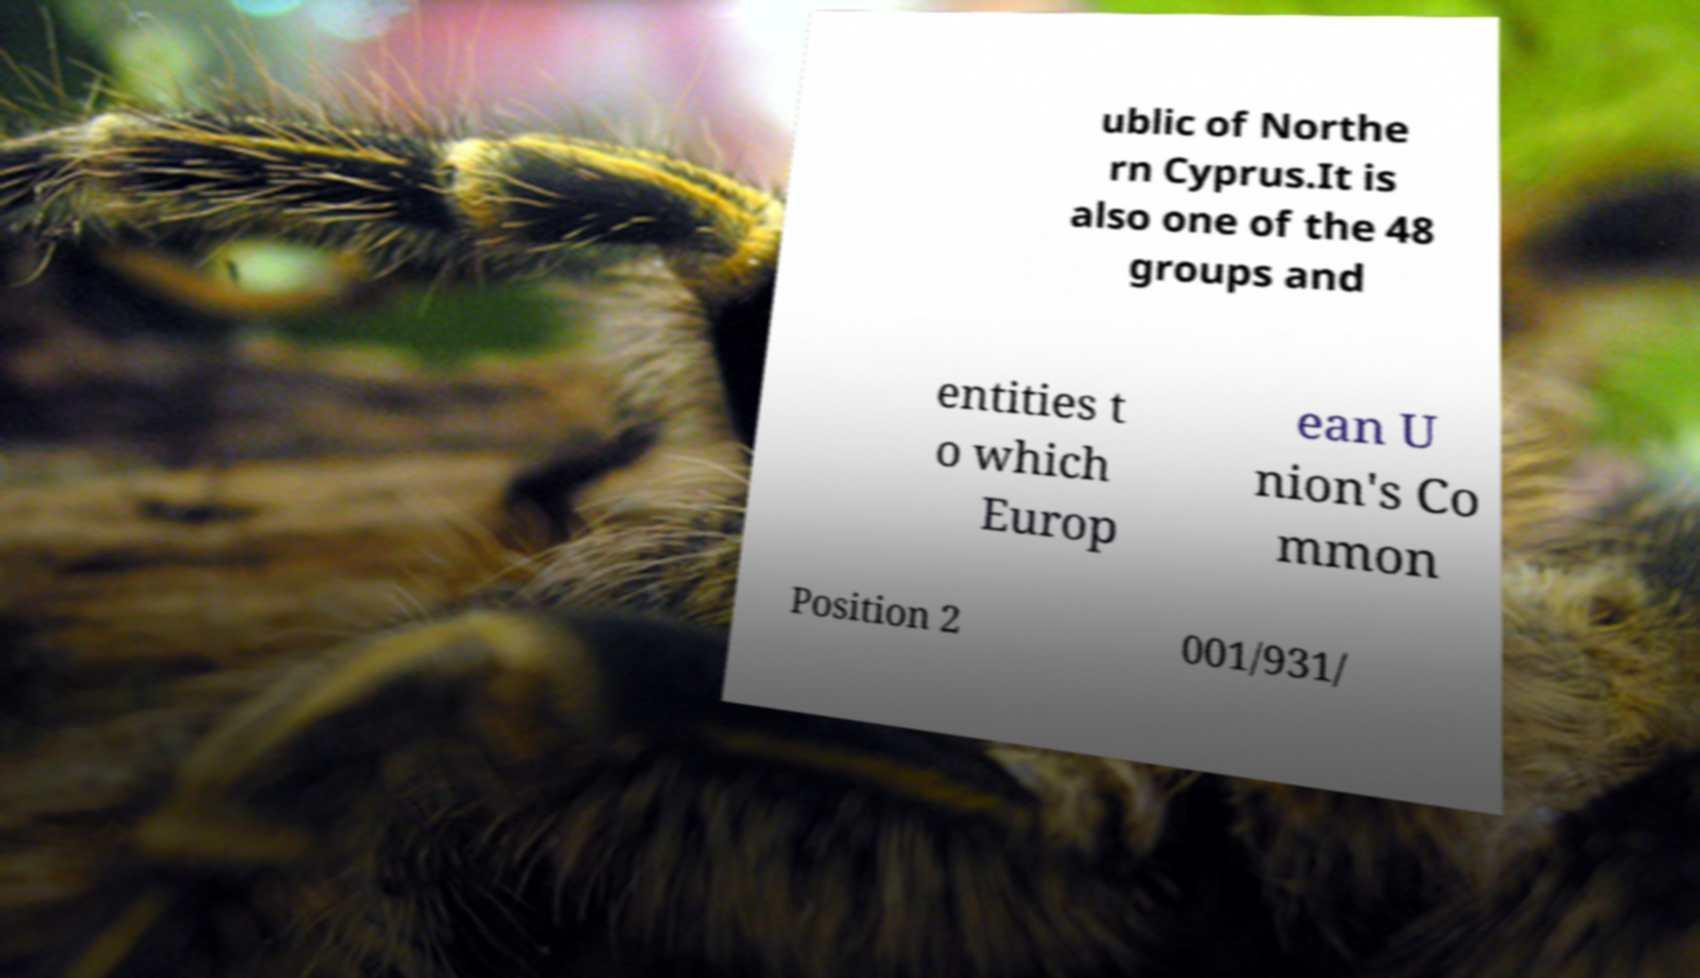What messages or text are displayed in this image? I need them in a readable, typed format. ublic of Northe rn Cyprus.It is also one of the 48 groups and entities t o which Europ ean U nion's Co mmon Position 2 001/931/ 